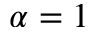Convert formula to latex. <formula><loc_0><loc_0><loc_500><loc_500>\alpha = 1</formula> 